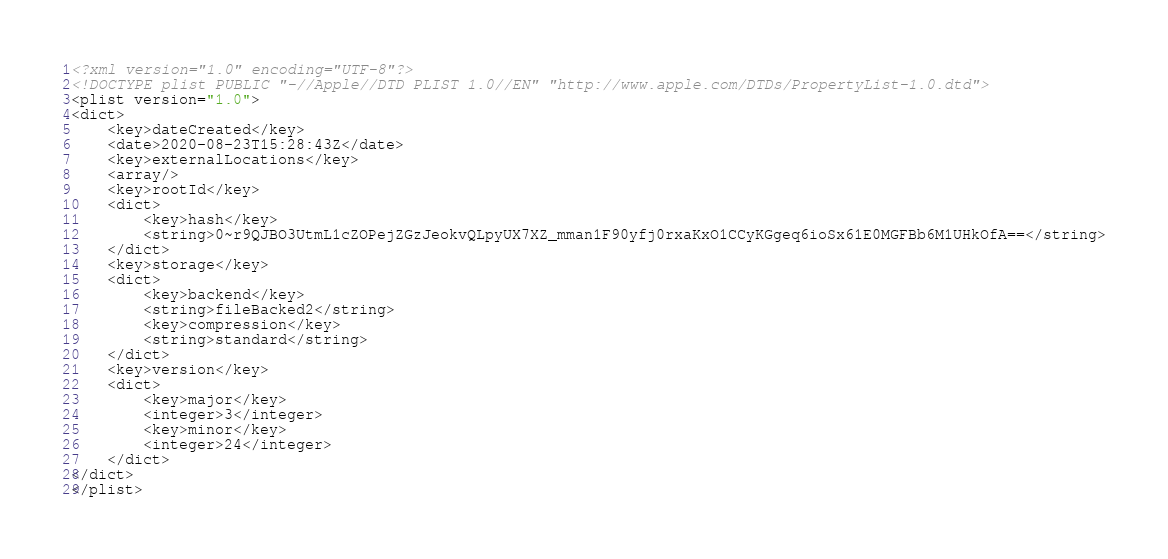<code> <loc_0><loc_0><loc_500><loc_500><_XML_><?xml version="1.0" encoding="UTF-8"?>
<!DOCTYPE plist PUBLIC "-//Apple//DTD PLIST 1.0//EN" "http://www.apple.com/DTDs/PropertyList-1.0.dtd">
<plist version="1.0">
<dict>
	<key>dateCreated</key>
	<date>2020-08-23T15:28:43Z</date>
	<key>externalLocations</key>
	<array/>
	<key>rootId</key>
	<dict>
		<key>hash</key>
		<string>0~r9QJBO3UtmL1cZOPejZGzJeokvQLpyUX7XZ_mman1F90yfj0rxaKxO1CCyKGgeq6ioSx61E0MGFBb6M1UHkOfA==</string>
	</dict>
	<key>storage</key>
	<dict>
		<key>backend</key>
		<string>fileBacked2</string>
		<key>compression</key>
		<string>standard</string>
	</dict>
	<key>version</key>
	<dict>
		<key>major</key>
		<integer>3</integer>
		<key>minor</key>
		<integer>24</integer>
	</dict>
</dict>
</plist>
</code> 